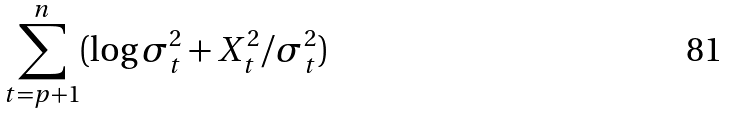Convert formula to latex. <formula><loc_0><loc_0><loc_500><loc_500>\sum _ { t = p + 1 } ^ { n } ( \log \sigma ^ { 2 } _ { t } + X ^ { 2 } _ { t } / \sigma ^ { 2 } _ { t } )</formula> 